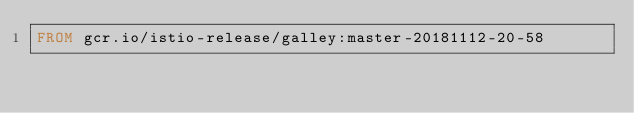Convert code to text. <code><loc_0><loc_0><loc_500><loc_500><_Dockerfile_>FROM gcr.io/istio-release/galley:master-20181112-20-58
</code> 